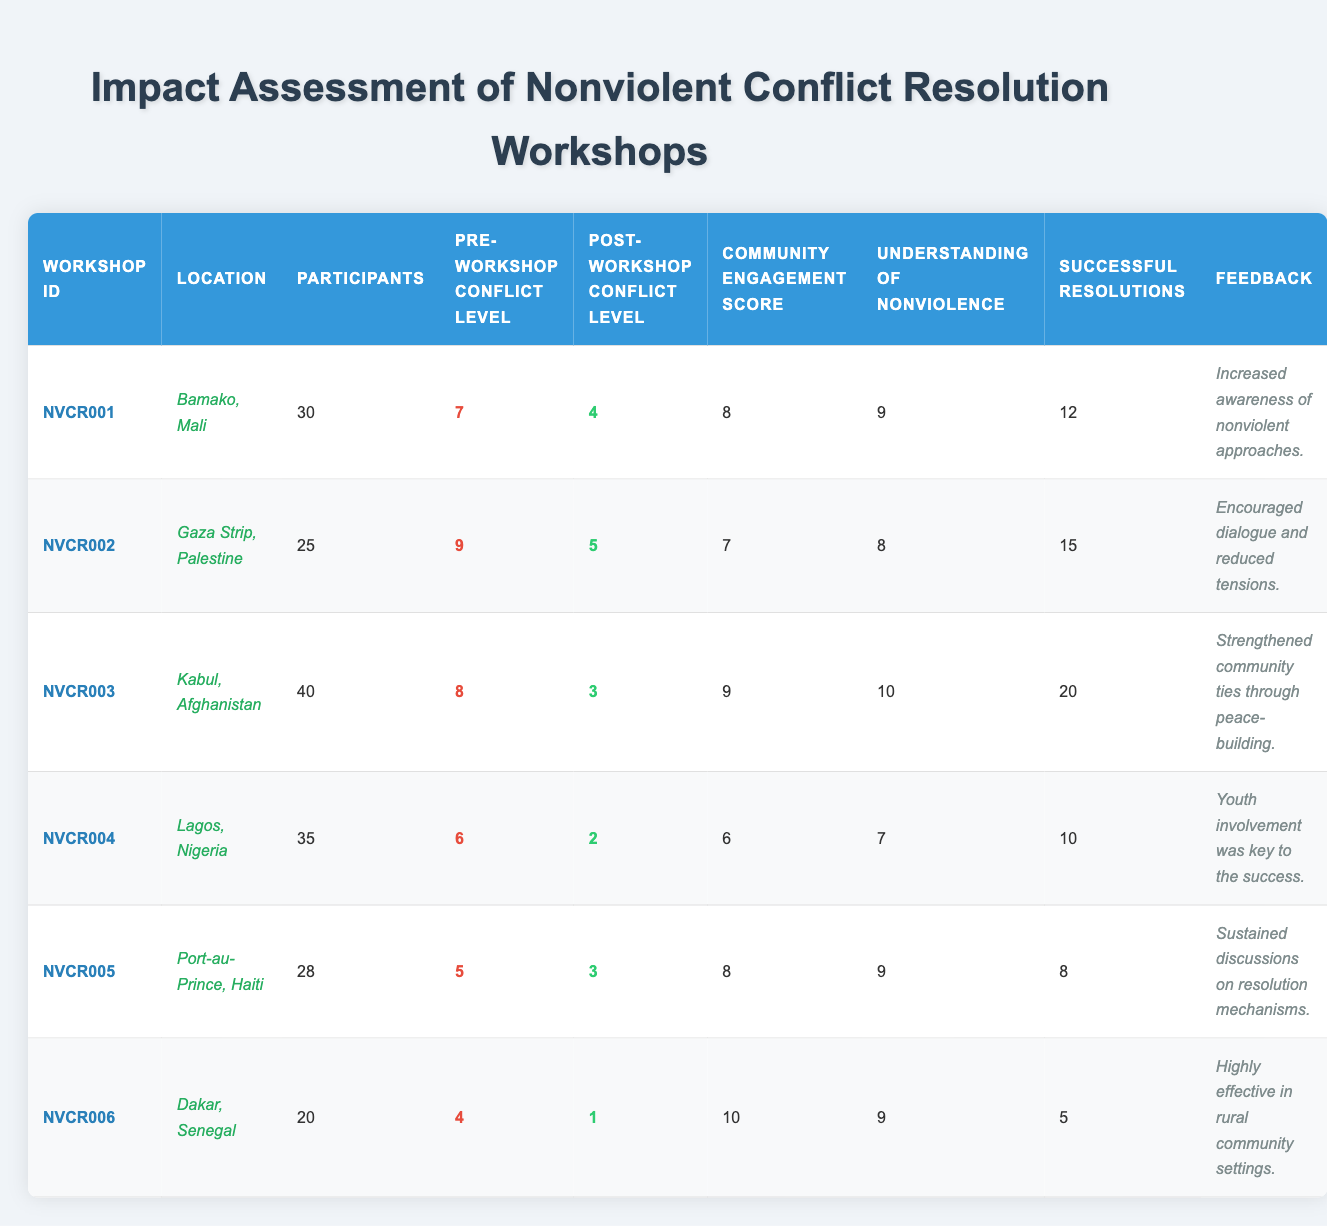What is the location of workshop NVCR004? The table lists the location for workshop NVCR004 as "Lagos, Nigeria."
Answer: Lagos, Nigeria How many participants attended the workshop in Bamako, Mali? The number of participants for workshop NVCR001 is stated in the table as 30.
Answer: 30 What was the pre-workshop conflict level for the workshop with the highest number of successful resolutions? Workshop NVCR003 in Kabul, Afghanistan had the highest number of successful resolutions (20), with a pre-workshop conflict level of 8.
Answer: 8 What is the average community engagement score across all workshops? The community engagement scores are: 8, 7, 9, 6, 8, 10. Summing these gives 48. There are 6 workshops, so the average is 48/6 = 8.
Answer: 8 Did any workshop have a post-workshop conflict level lower than 2? The workshop in Lagos, Nigeria (NVCR004) had a post-workshop conflict level of 2. Therefore, it does not have a post-workshop level lower than 2.
Answer: No Which workshop had the highest post-workshop conflict level? The highest post-workshop conflict level is 5 from the Gaza Strip, Palestine (NVCR002).
Answer: 5 Was the understanding of nonviolence greater than 9 for any workshop? Yes, NVCR003 in Kabul, Afghanistan had an understanding of nonviolence at 10, which is greater than 9.
Answer: Yes What was the change in conflict level from pre-workshop to post-workshop for the participants in Dakar, Senegal? The pre-workshop conflict level in Dakar (NVCR006) was 4, and the post-workshop level was 1. The change is 4 - 1 = 3.
Answer: 3 